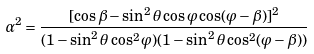Convert formula to latex. <formula><loc_0><loc_0><loc_500><loc_500>\alpha ^ { 2 } = \frac { [ \cos \beta - \sin ^ { 2 } \theta \cos \varphi \cos ( \varphi - \beta ) ] ^ { 2 } } { ( 1 - \sin ^ { 2 } \theta \cos ^ { 2 } \varphi ) ( 1 - \sin ^ { 2 } \theta \cos ^ { 2 } ( \varphi - \beta ) ) }</formula> 